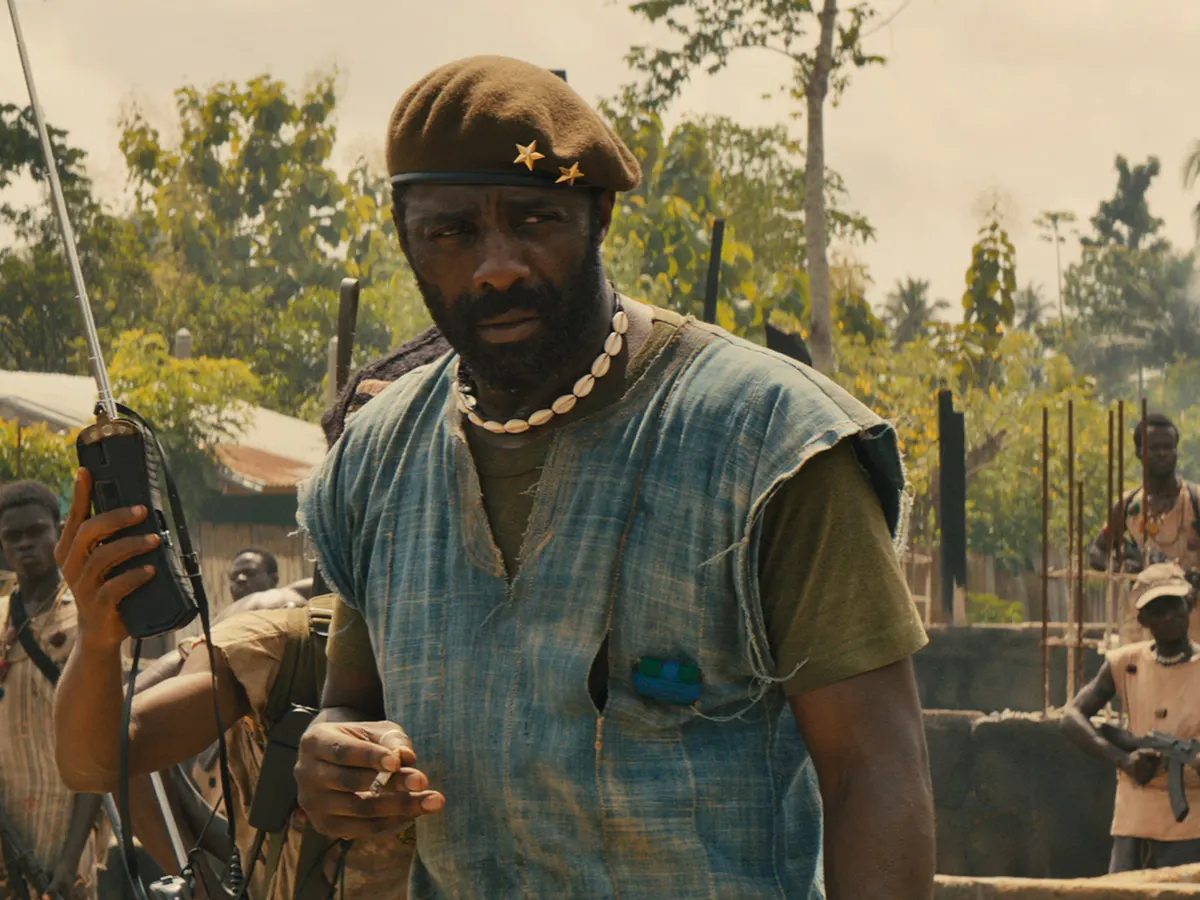Can you narrate a short story based on the scene in the image? In a secluded village, swallowed by the remnants of a past war and the whispers of ongoing conflict, a figure of resolve stood tall. The Commandant, clad in a weary blue tunic and a green vest, radiated an aura of unyielding authority. His green beret, sitting snugly atop his head, bore two gold stars that glinted dully in the harsh sunlight. Around his neck, a string of white beads clashed subtly with the rugged, utilitarian look, whispering tales of a gentler past and the cultural roots he fiercely clung to. In his right hand, the walkie-talkie crackled sporadically, a lifeline to his disparate troops, scattered across the fringes of the village. On his left shoulder, a well-worn gun rested, a stark reminder of the omnipresent danger lurking in every shadow. Behind him, his men, bound by loyalty and necessity, hung on his every word, their eyes mirroring a complex brew of fear and determination. The oppressive heat of the day clung to their skin, mingling with the tension that sharpened the air. Trees loomed in the background, their foliage sparse as if the land itself had grown weary of the endless strife. Together, they stood on the brink of yet another confrontation, their fate intertwined with the dusty winds of the war-torn fields. What are some possible backgrounds or contexts for the conflict in the image? The conflict depicted in the image could stem from several contexts. One possibility is a civil war, where different factions vie for control of the country, driven by ethnic, political, or ideological differences. Another scenario could involve a resistance movement fighting against a tyrannical regime, aiming to liberate oppressed communities. Alternatively, it could be an external conflict, with the village caught in the crossfire between warring nations or factions. The struggle could also be resource-based, with various groups attempting to seize control over valuable natural resources like minerals, oil, or arable land. Each of these contexts would shape the motivations, strategies, and dynamics of the individuals involved, influencing both the immediate atmosphere and the broader narrative of the conflict. 